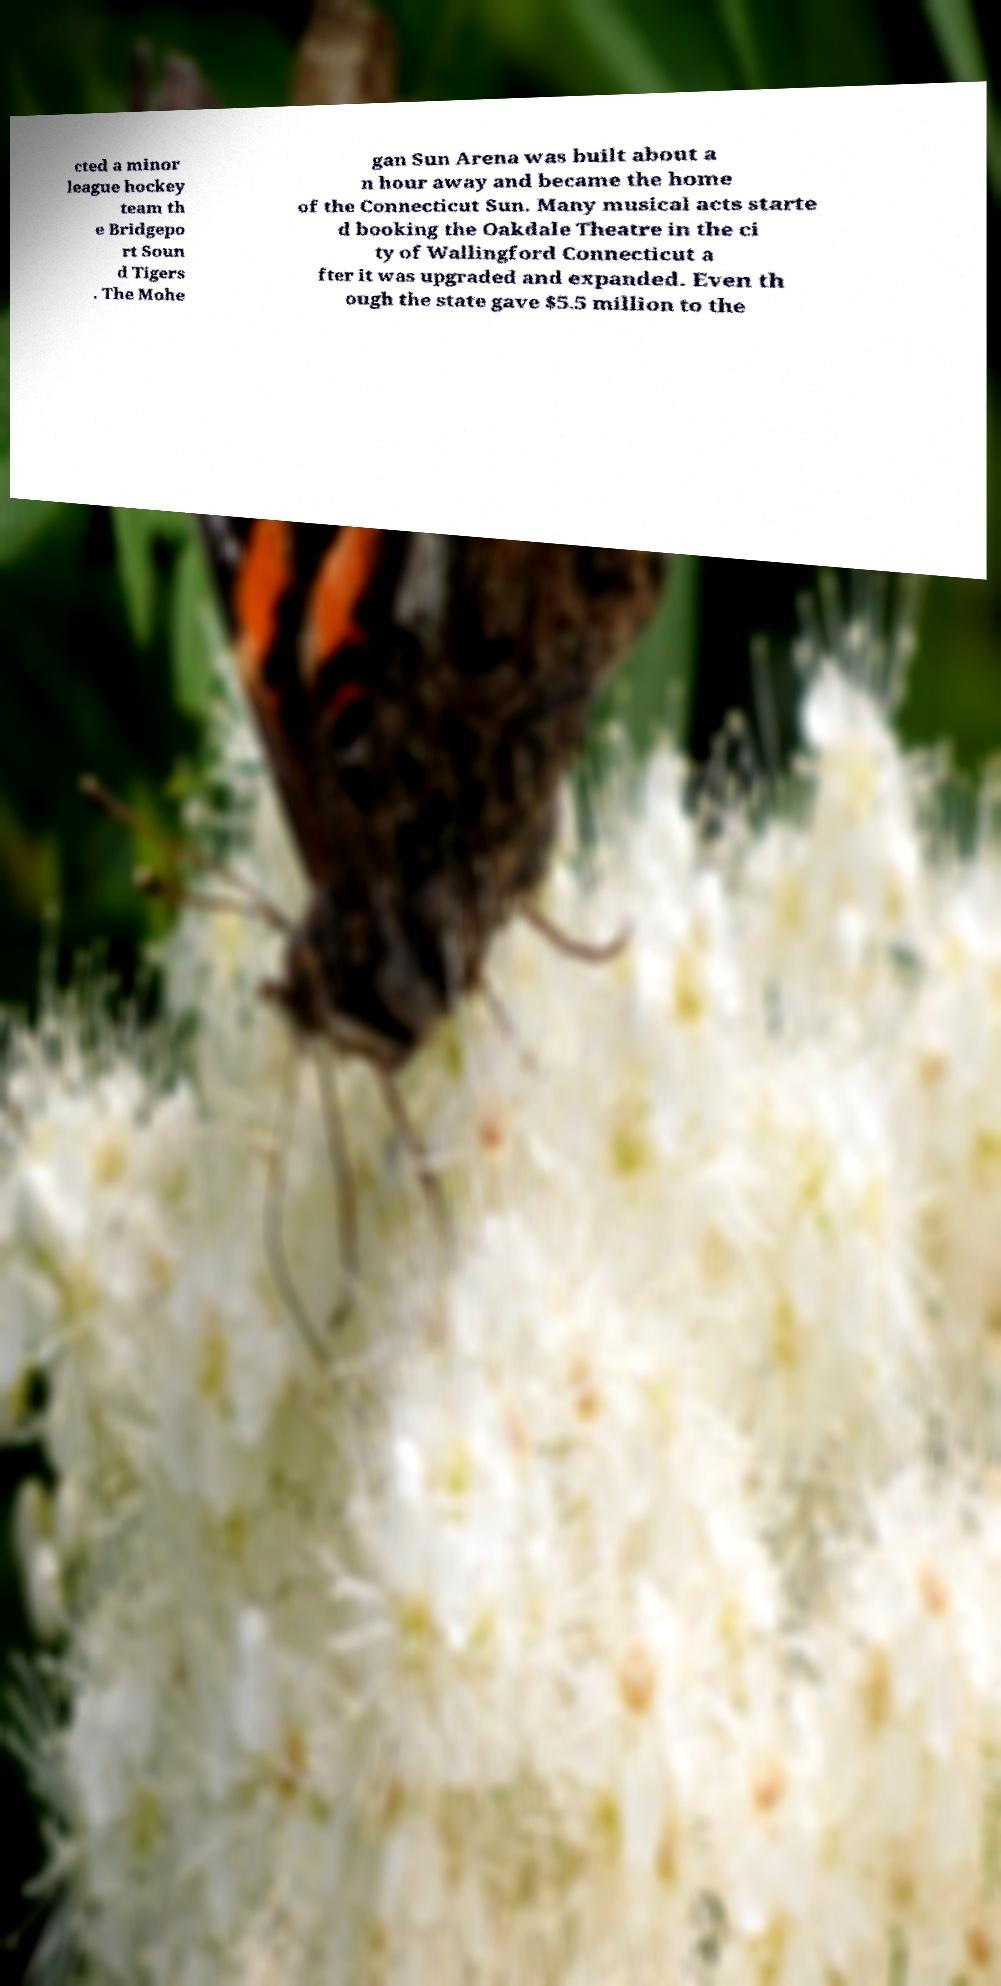What messages or text are displayed in this image? I need them in a readable, typed format. cted a minor league hockey team th e Bridgepo rt Soun d Tigers . The Mohe gan Sun Arena was built about a n hour away and became the home of the Connecticut Sun. Many musical acts starte d booking the Oakdale Theatre in the ci ty of Wallingford Connecticut a fter it was upgraded and expanded. Even th ough the state gave $5.5 million to the 